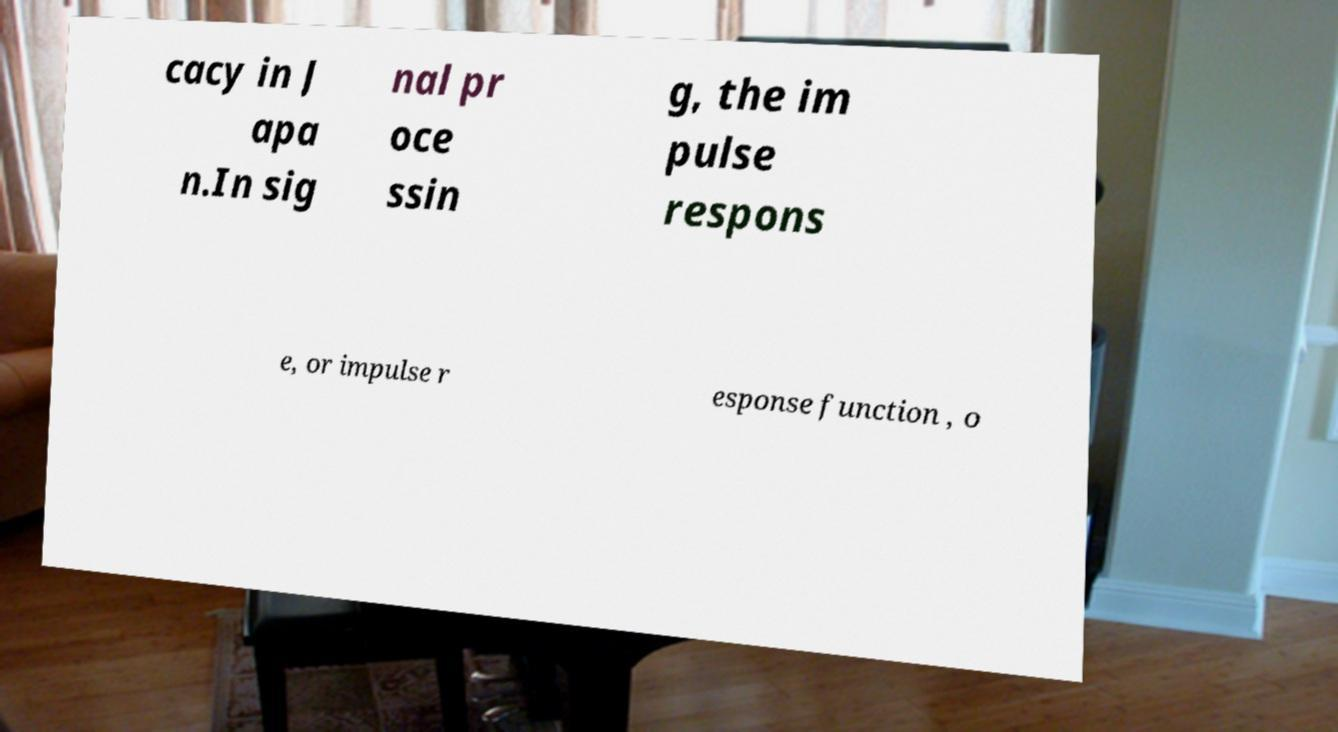Could you extract and type out the text from this image? cacy in J apa n.In sig nal pr oce ssin g, the im pulse respons e, or impulse r esponse function , o 